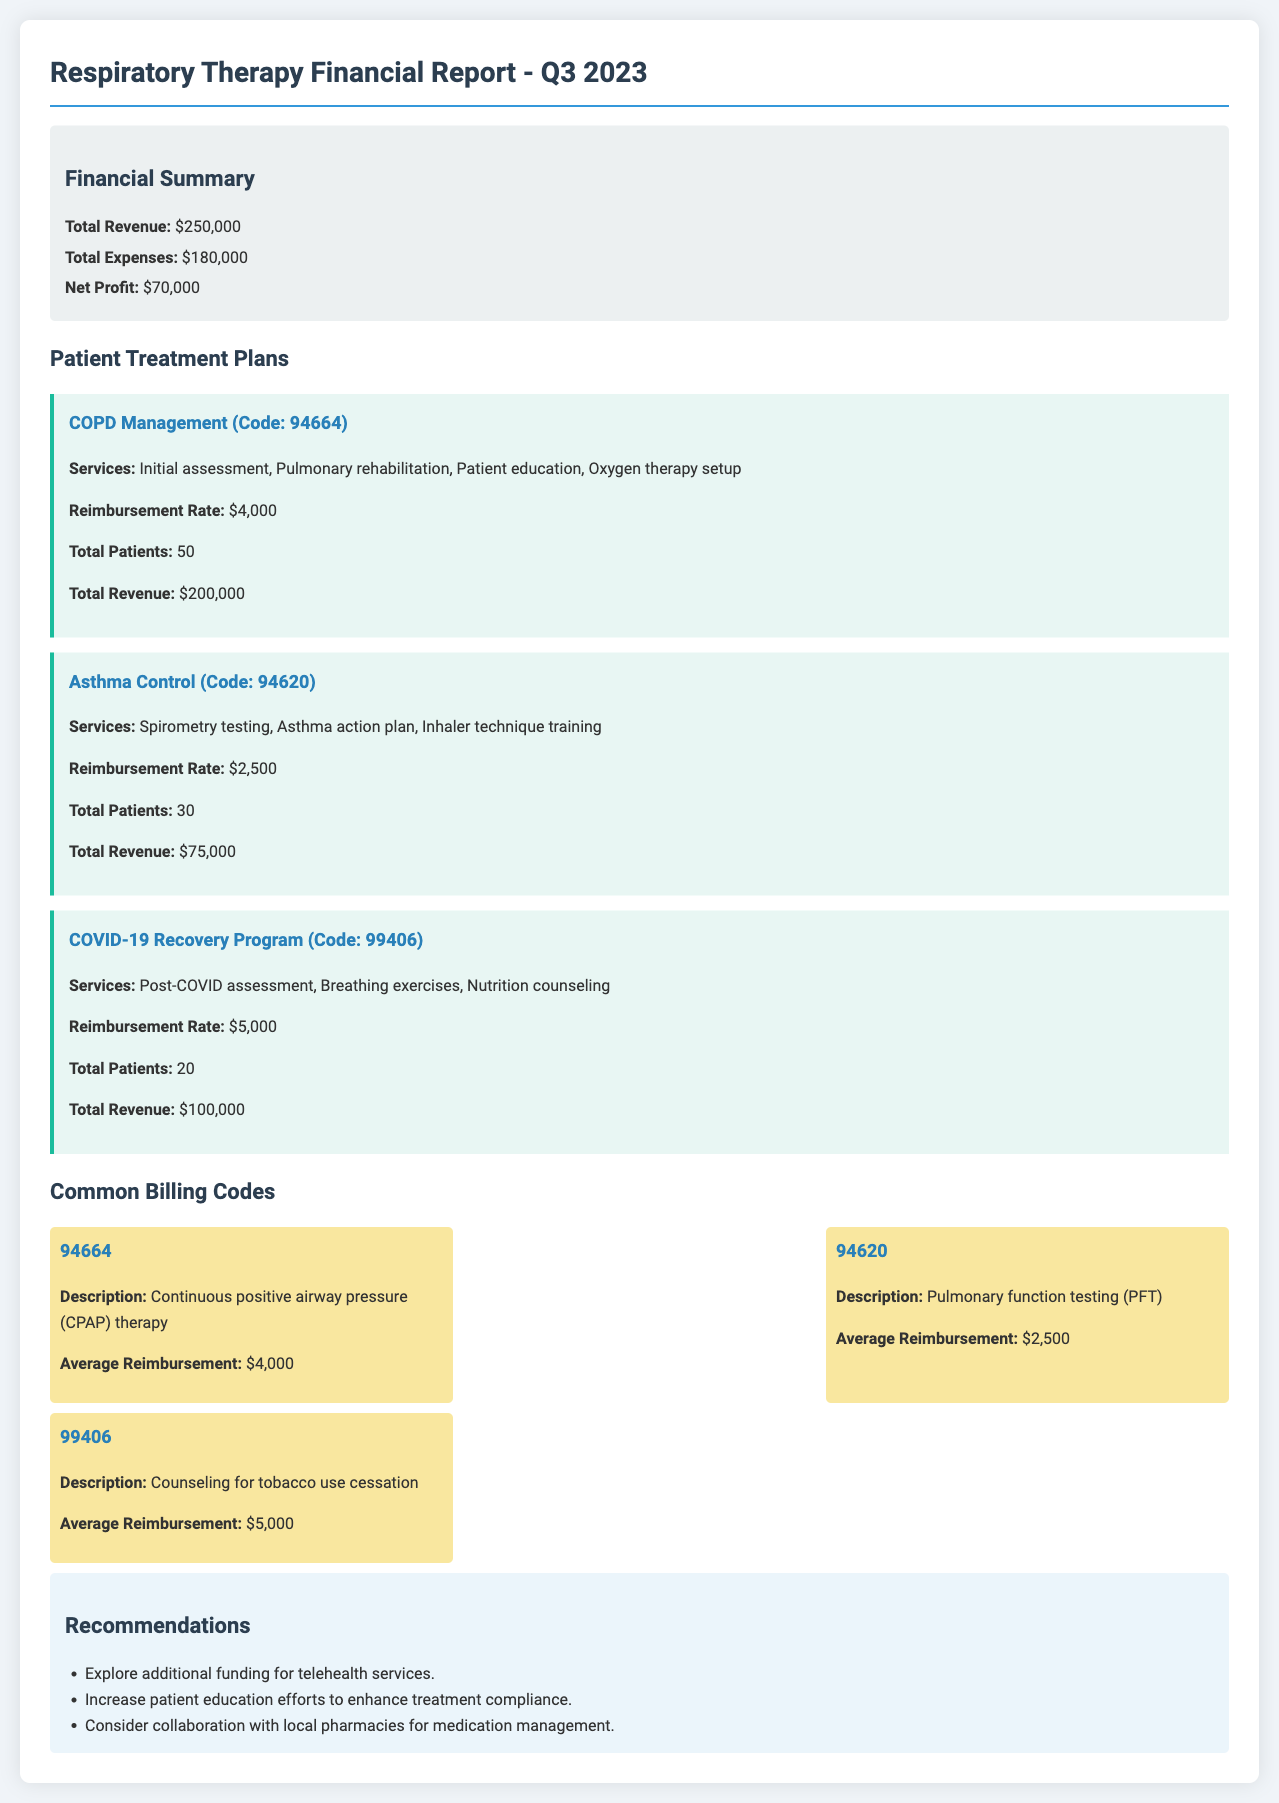What was the total revenue for Q3 2023? The total revenue is stated in the financial summary and amounts to $250,000.
Answer: $250,000 What is the net profit reported in the document? The net profit is the difference between total revenue and total expenses, which is explicitly mentioned in the financial summary as $70,000.
Answer: $70,000 How many patients were treated under the Asthma Control plan? The document specifies that a total of 30 patients were treated under the Asthma Control plan.
Answer: 30 What is the reimbursement rate for the COPD Management plan? The document lists the reimbursement rate for the COPD Management plan as $4,000.
Answer: $4,000 Which billing code corresponds to the COVID-19 Recovery Program? The billing code for the COVID-19 Recovery Program is indicated as 99406.
Answer: 99406 How much total revenue was generated from the COVID-19 Recovery Program? The total revenue generated from the COVID-19 Recovery Program is detailed in the document as $100,000.
Answer: $100,000 What average reimbursement is associated with the billing code 94620? The document indicates the average reimbursement for billing code 94620 is $2,500.
Answer: $2,500 What recommendation is made regarding telehealth services? One of the recommendations suggests exploring additional funding for telehealth services.
Answer: Additional funding for telehealth services What is the total expense reported for Q3 2023? The total expense reported in the document is $180,000, as shown in the financial summary.
Answer: $180,000 